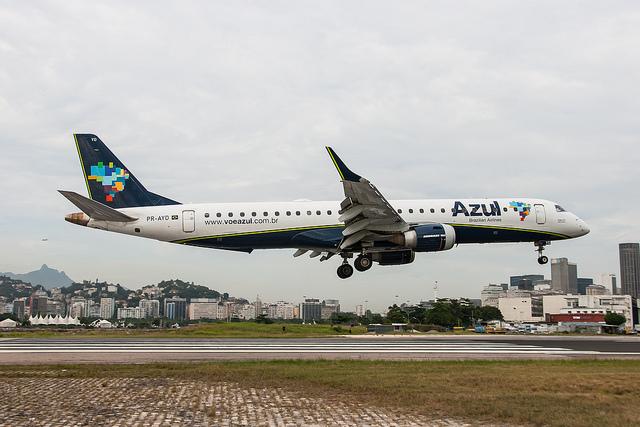Does this look like a new plane?
Concise answer only. Yes. Is this airplane on the runway?
Concise answer only. No. Is this a commercial airline?
Short answer required. Yes. What kind of vehicle is shown?
Give a very brief answer. Airplane. What is the name of the plane?
Give a very brief answer. Azul. 